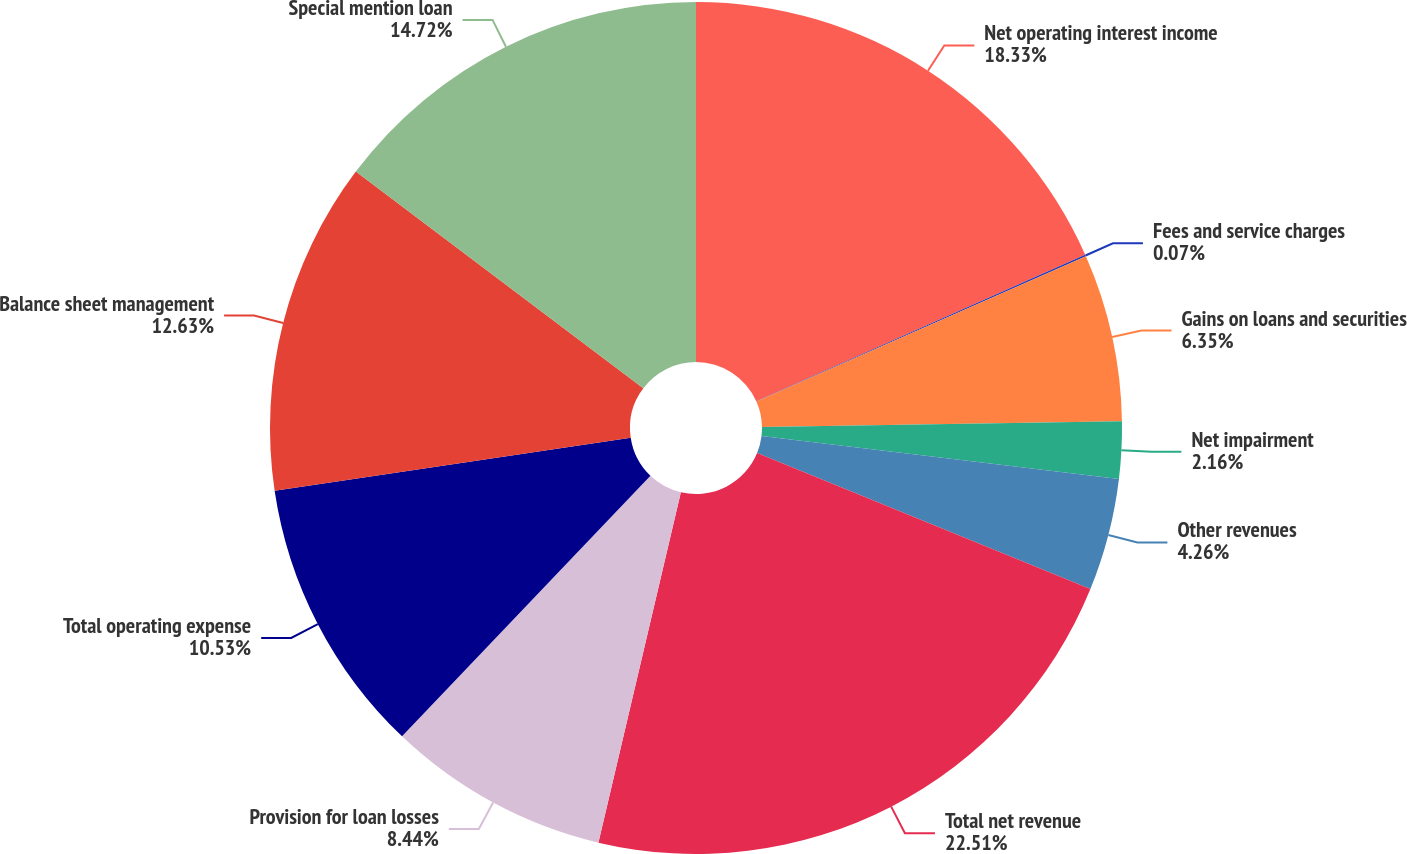Convert chart to OTSL. <chart><loc_0><loc_0><loc_500><loc_500><pie_chart><fcel>Net operating interest income<fcel>Fees and service charges<fcel>Gains on loans and securities<fcel>Net impairment<fcel>Other revenues<fcel>Total net revenue<fcel>Provision for loan losses<fcel>Total operating expense<fcel>Balance sheet management<fcel>Special mention loan<nl><fcel>18.33%<fcel>0.07%<fcel>6.35%<fcel>2.16%<fcel>4.26%<fcel>22.51%<fcel>8.44%<fcel>10.53%<fcel>12.63%<fcel>14.72%<nl></chart> 